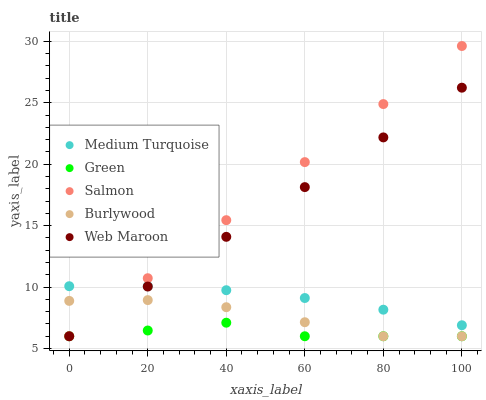Does Green have the minimum area under the curve?
Answer yes or no. Yes. Does Salmon have the maximum area under the curve?
Answer yes or no. Yes. Does Salmon have the minimum area under the curve?
Answer yes or no. No. Does Green have the maximum area under the curve?
Answer yes or no. No. Is Salmon the smoothest?
Answer yes or no. Yes. Is Green the roughest?
Answer yes or no. Yes. Is Green the smoothest?
Answer yes or no. No. Is Salmon the roughest?
Answer yes or no. No. Does Burlywood have the lowest value?
Answer yes or no. Yes. Does Medium Turquoise have the lowest value?
Answer yes or no. No. Does Salmon have the highest value?
Answer yes or no. Yes. Does Green have the highest value?
Answer yes or no. No. Is Green less than Medium Turquoise?
Answer yes or no. Yes. Is Medium Turquoise greater than Green?
Answer yes or no. Yes. Does Medium Turquoise intersect Salmon?
Answer yes or no. Yes. Is Medium Turquoise less than Salmon?
Answer yes or no. No. Is Medium Turquoise greater than Salmon?
Answer yes or no. No. Does Green intersect Medium Turquoise?
Answer yes or no. No. 